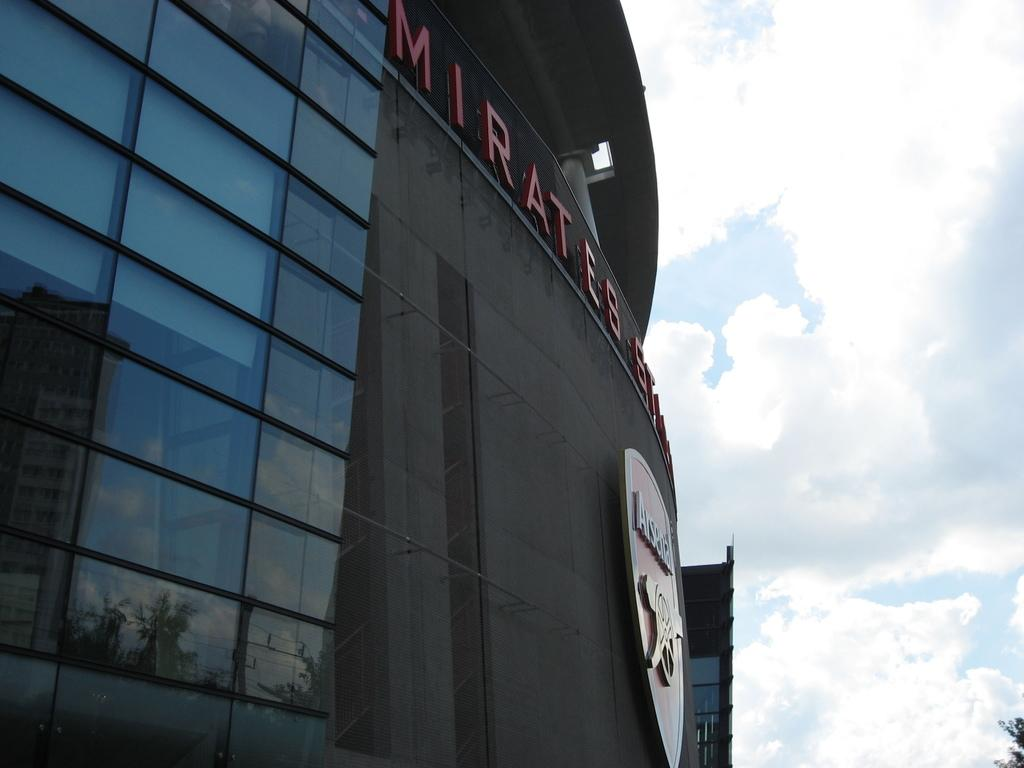What is the main subject of the image? The main subject of the image is a building with a board and text. What can be seen on the right side of the image? There is a tree on the right side of the image. How does the tree appear in the image? The tree appears to be truncated. What is visible in the background of the image? The sky is visible in the background of the image. What can be observed in the sky? There are clouds in the sky. What type of toy can be seen playing with the text on the board in the image? There is no toy present in the image, and therefore no such activity can be observed. 